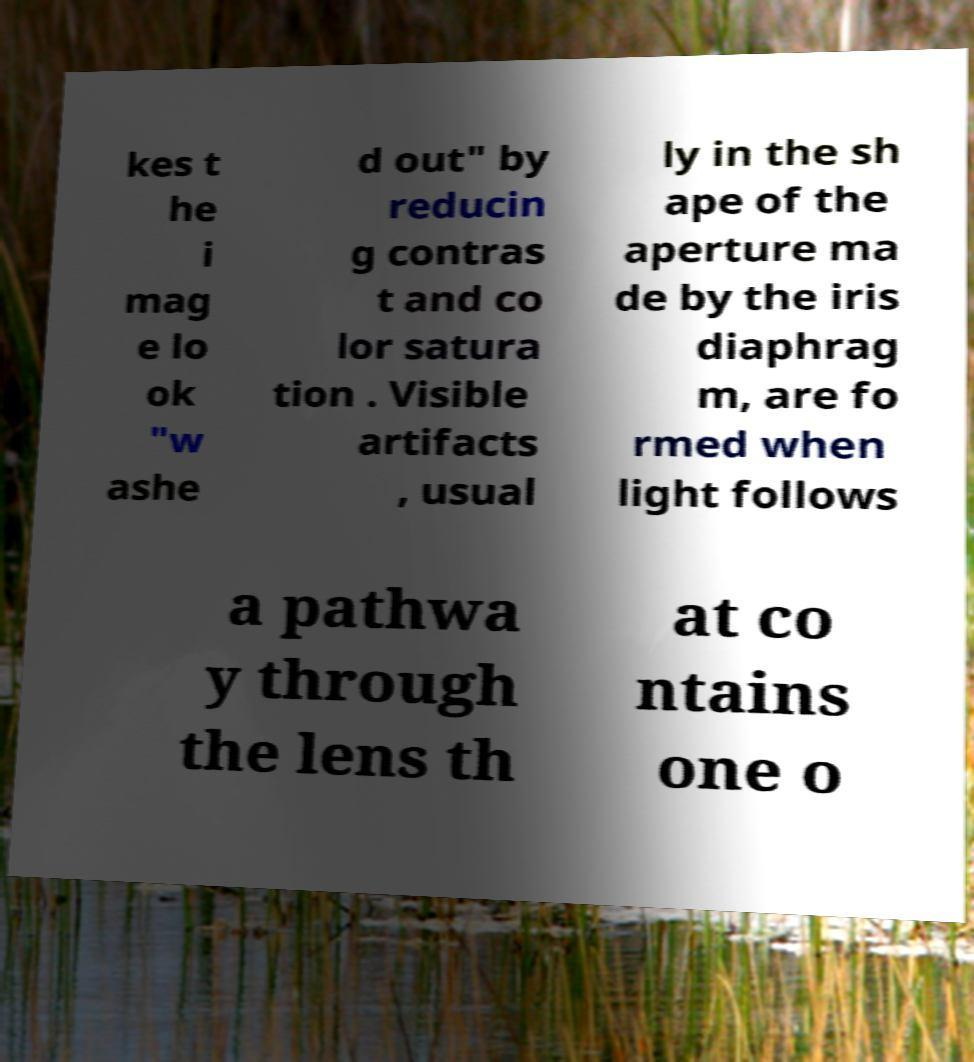Could you extract and type out the text from this image? kes t he i mag e lo ok "w ashe d out" by reducin g contras t and co lor satura tion . Visible artifacts , usual ly in the sh ape of the aperture ma de by the iris diaphrag m, are fo rmed when light follows a pathwa y through the lens th at co ntains one o 